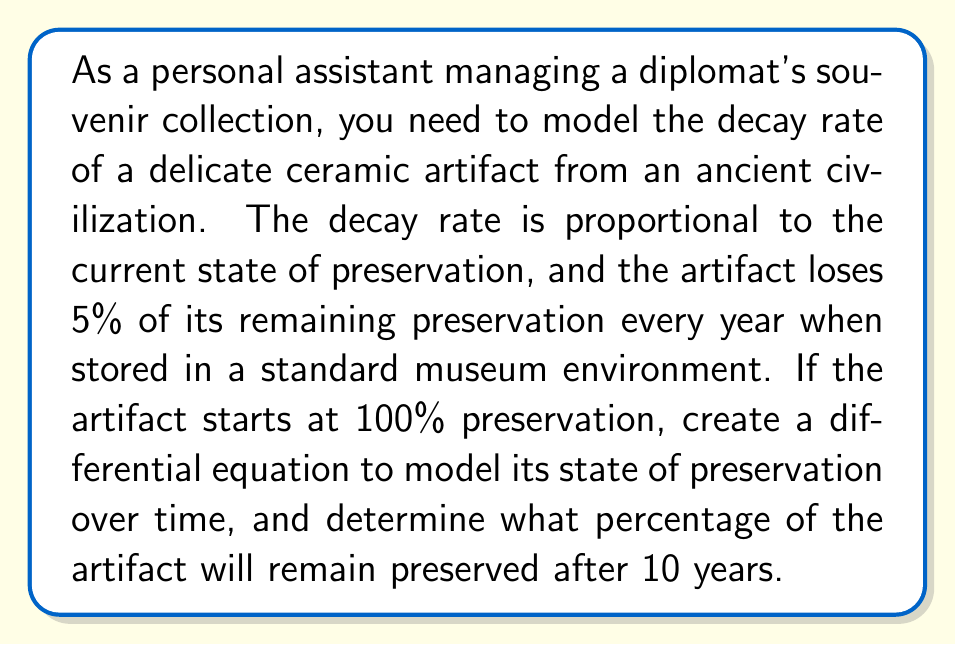Provide a solution to this math problem. Let's approach this step-by-step:

1) Let $P(t)$ represent the percentage of the artifact preserved at time $t$ (in years).

2) The decay rate is proportional to the current state of preservation. This can be expressed as:

   $$\frac{dP}{dt} = -kP$$

   where $k$ is the decay constant.

3) We're told that the artifact loses 5% of its remaining preservation every year. This means that after one year, 95% of the original amount remains. We can use this to find $k$:

   $$P(1) = P(0)e^{-k(1)}$$
   $$0.95 = e^{-k}$$
   $$\ln(0.95) = -k$$
   $$k = -\ln(0.95) \approx 0.0513$$

4) Now our differential equation is:

   $$\frac{dP}{dt} = -0.0513P$$

5) The general solution to this differential equation is:

   $$P(t) = Ce^{-0.0513t}$$

   where $C$ is a constant determined by the initial conditions.

6) We know that $P(0) = 100$ (starts at 100% preservation), so:

   $$100 = Ce^{-0.0513(0)}$$
   $$100 = C$$

7) Therefore, our specific solution is:

   $$P(t) = 100e^{-0.0513t}$$

8) To find the percentage preserved after 10 years, we calculate $P(10)$:

   $$P(10) = 100e^{-0.0513(10)} \approx 59.87$$

Thus, approximately 59.87% of the artifact will remain preserved after 10 years.
Answer: After 10 years, approximately 59.87% of the artifact will remain preserved. 